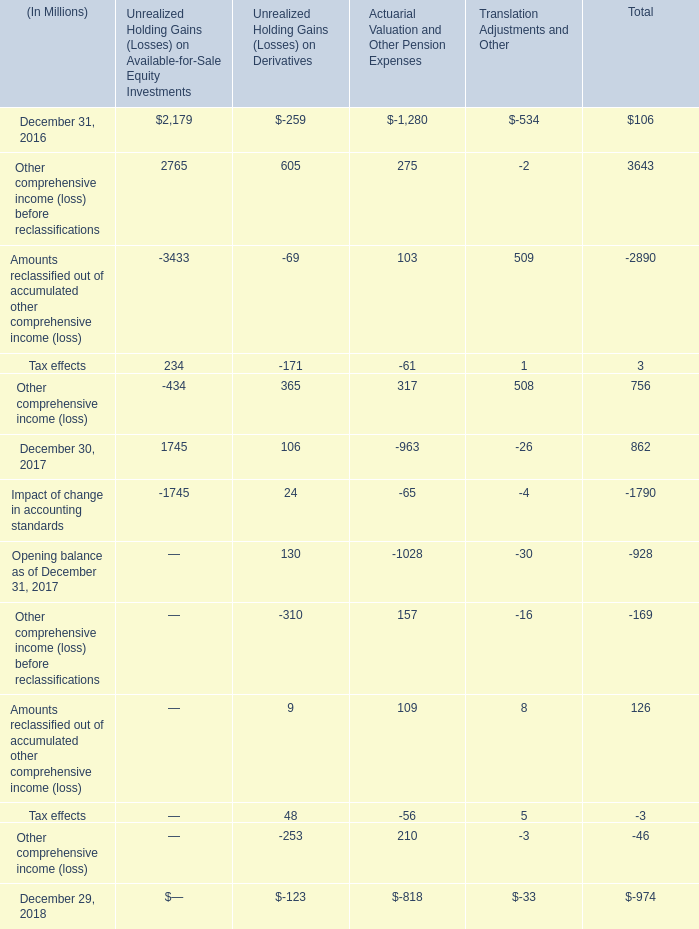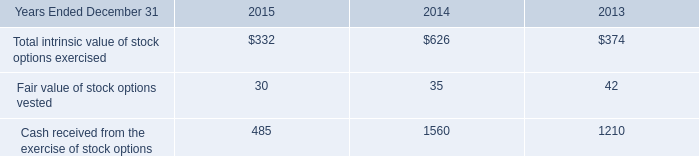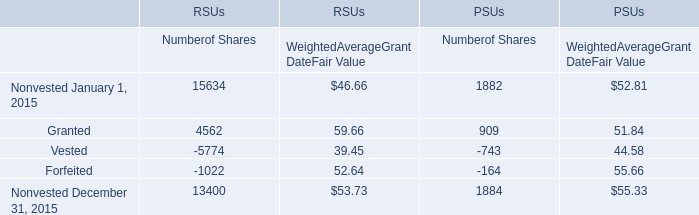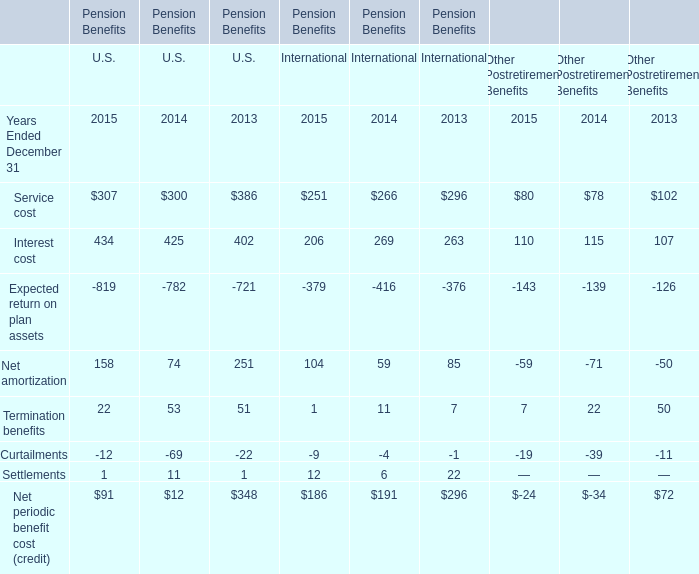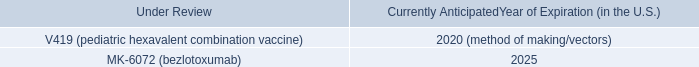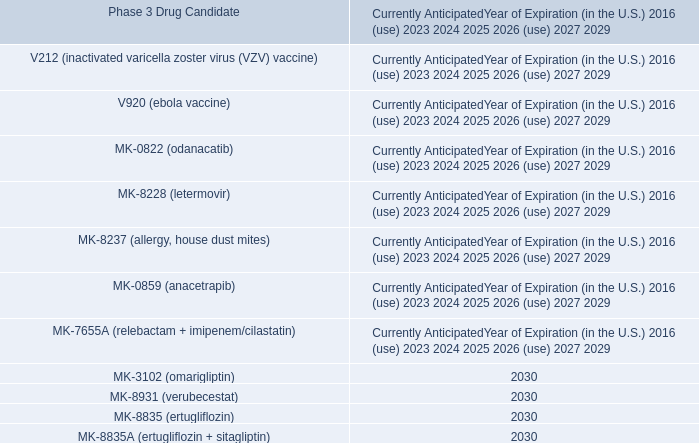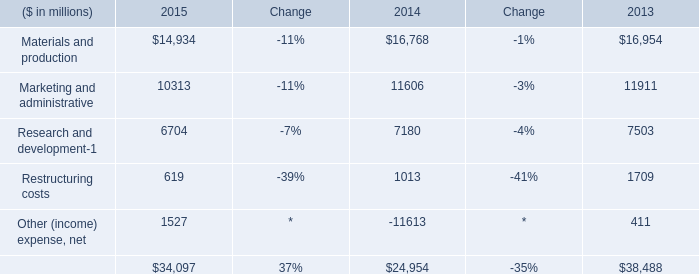What was the total amount of U.S. in the range of 0 and 400 in 2015? 
Computations: (((307 + 158) + 22) + 1)
Answer: 488.0. 